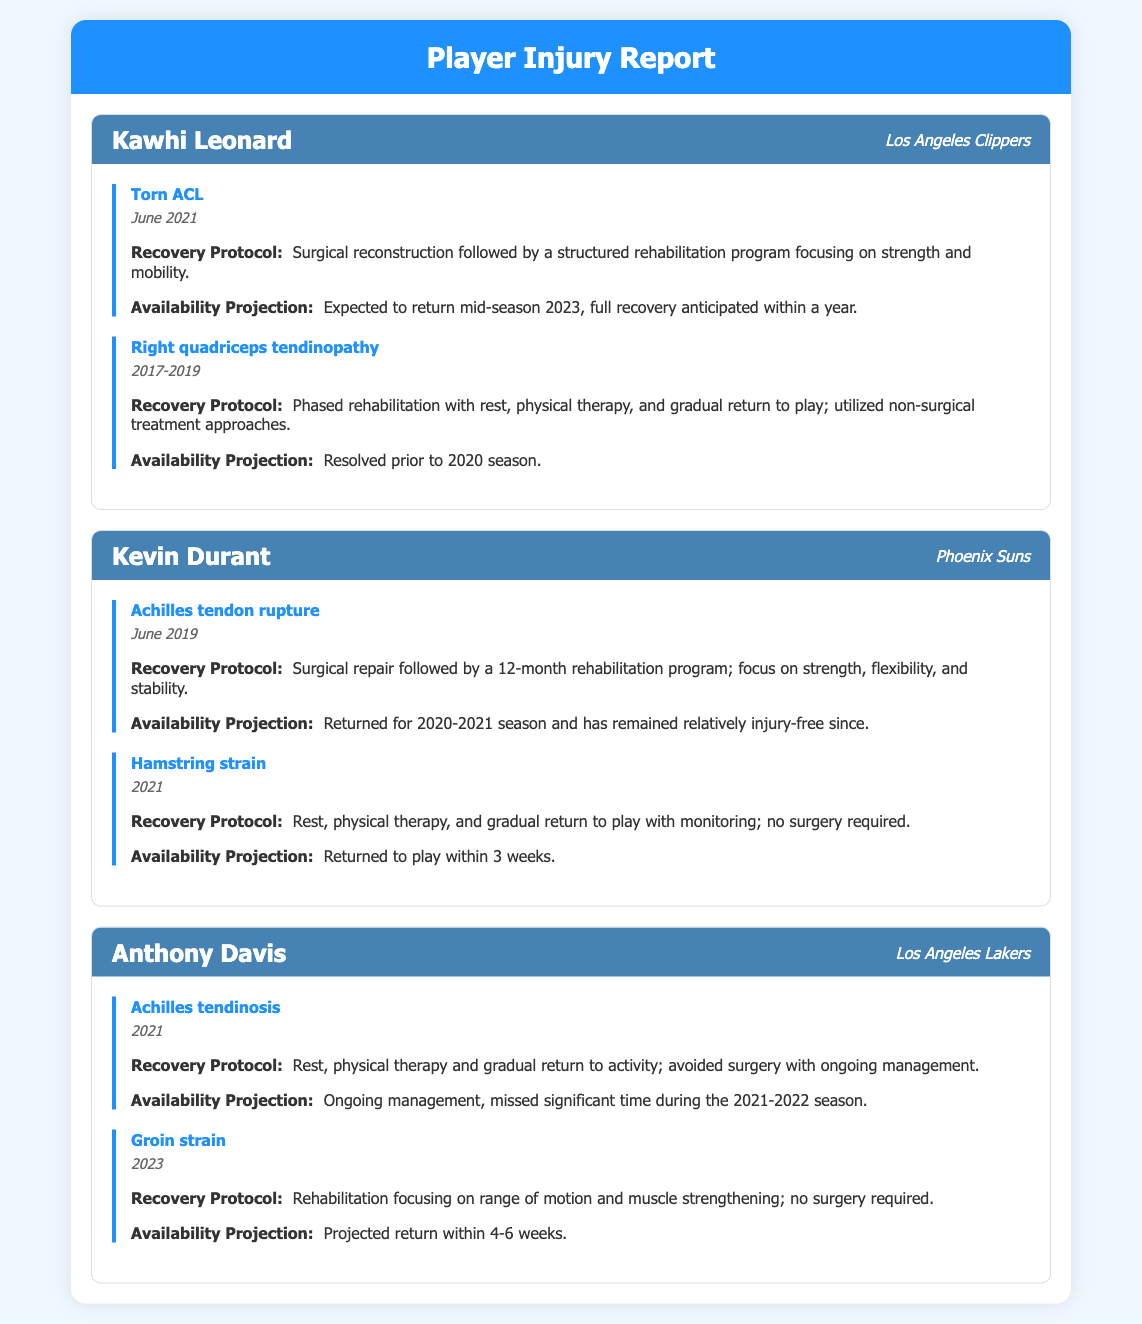What injury did Kawhi Leonard suffer? The document specifies that Kawhi Leonard suffered a torn ACL.
Answer: Torn ACL When did Kevin Durant have his Achilles tendon injury? The document mentions that Kevin Durant had an Achilles tendon rupture in June 2019.
Answer: June 2019 What is Anthony Davis's projected return timeline for his groin strain? The document indicates that Anthony Davis's projected return is within 4-6 weeks.
Answer: 4-6 weeks What recovery protocol did Kawhi Leonard undergo for his torn ACL? The recovery protocol included surgical reconstruction followed by a structured rehabilitation program.
Answer: Surgical reconstruction How long was Kevin Durant's rehabilitation program for his Achilles tendon rupture? The document states that Kevin Durant's rehabilitation program lasted 12 months.
Answer: 12 months What injury did Anthony Davis miss significant time for during the 2021-2022 season? The document describes that Anthony Davis missed significant time due to Achilles tendinosis.
Answer: Achilles tendinosis What treatment did Kevin Durant receive for his hamstring strain? The document notes that he underwent rest, physical therapy, and a gradual return to play.
Answer: Rest, physical therapy What type of injury did Kawhi Leonard deal with during 2017-2019? The document reveals he dealt with right quadriceps tendinopathy during that time.
Answer: Right quadriceps tendinopathy What team does Kevin Durant play for? The document clearly states that Kevin Durant plays for the Phoenix Suns.
Answer: Phoenix Suns 